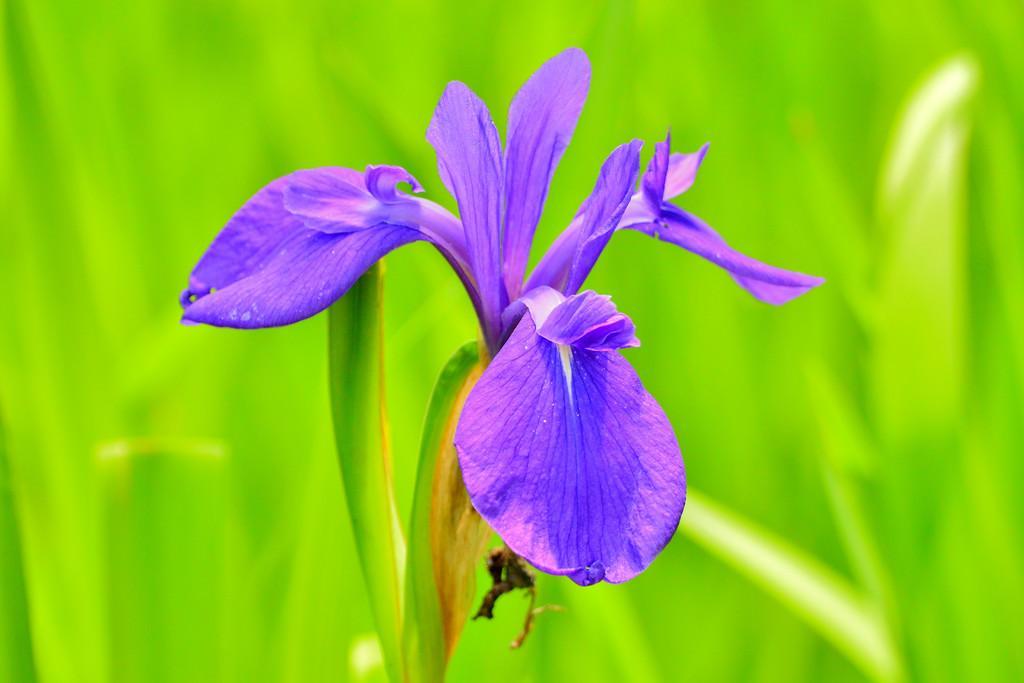Could you give a brief overview of what you see in this image? In this picture there is a flower in the center of the image. 